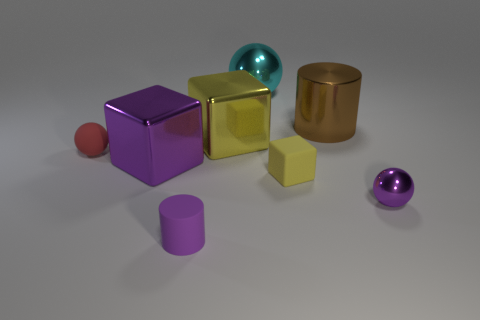Can you describe the shapes and colors of the objects present in the image? Certainly! The image contains a variety of geometric shapes. There's a large purple cube with a reflective surface, a gold metallic cube, a yellow cube with a matte finish, a small red sphere, a large teal sphere with a shiny surface, a bronze cylindrical container, and a purple cylinder.  How do the textures of the objects vary? In the image, textures range from matte to highly reflective. The yellow cube and purple cylinder have matte finishes, diffusing light evenly. In contrast, the large purple cube, gold cube, and teal sphere have reflective metallic surfaces that catch the light and create highlights. The bronze cylinder appears smooth with a less reflective metallic finish, and the small red sphere seems to have a slightly velvety texture. 